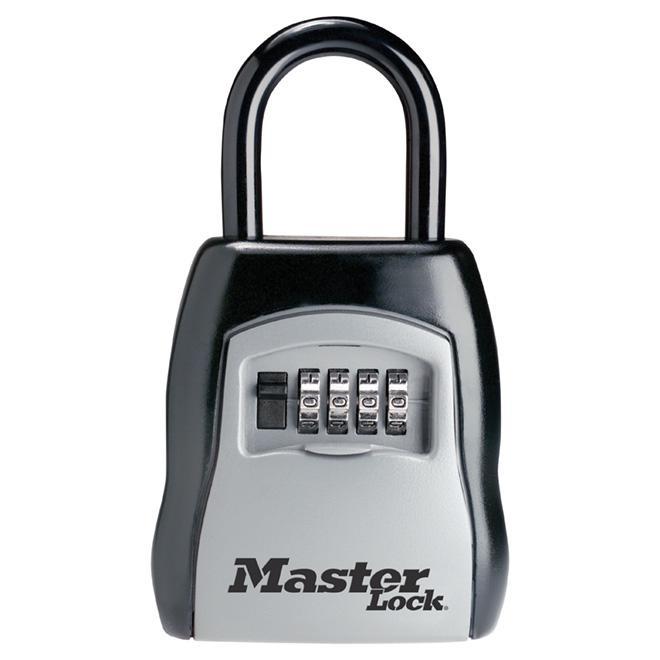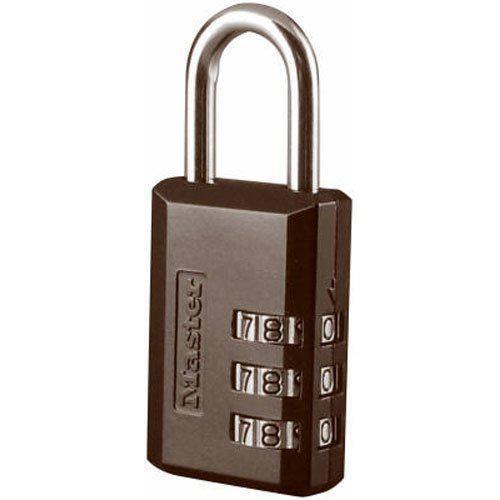The first image is the image on the left, the second image is the image on the right. Considering the images on both sides, is "Exactly two locks are shown, both of them locked and with a circular design and logo on the front, one with ridges on each side." valid? Answer yes or no. No. The first image is the image on the left, the second image is the image on the right. Considering the images on both sides, is "Each image contains just one lock, which is upright and has a blue circle on the front." valid? Answer yes or no. No. 